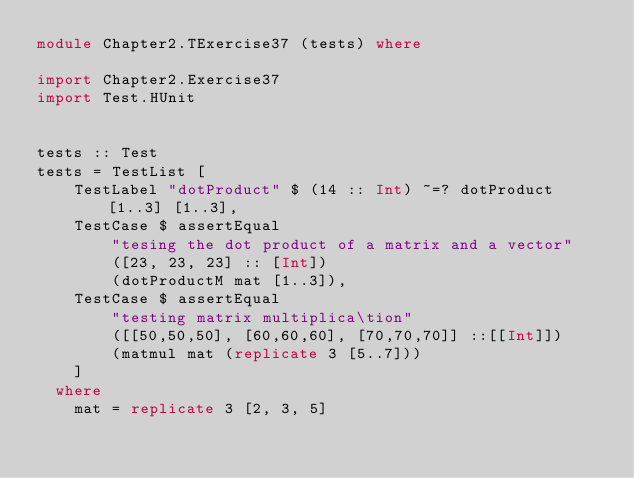<code> <loc_0><loc_0><loc_500><loc_500><_Haskell_>module Chapter2.TExercise37 (tests) where

import Chapter2.Exercise37
import Test.HUnit


tests :: Test
tests = TestList [
    TestLabel "dotProduct" $ (14 :: Int) ~=? dotProduct [1..3] [1..3],
    TestCase $ assertEqual
        "tesing the dot product of a matrix and a vector"
        ([23, 23, 23] :: [Int])
        (dotProductM mat [1..3]),
    TestCase $ assertEqual
        "testing matrix multiplica\tion"
        ([[50,50,50], [60,60,60], [70,70,70]] ::[[Int]])
        (matmul mat (replicate 3 [5..7]))
    ]
  where
    mat = replicate 3 [2, 3, 5]


</code> 